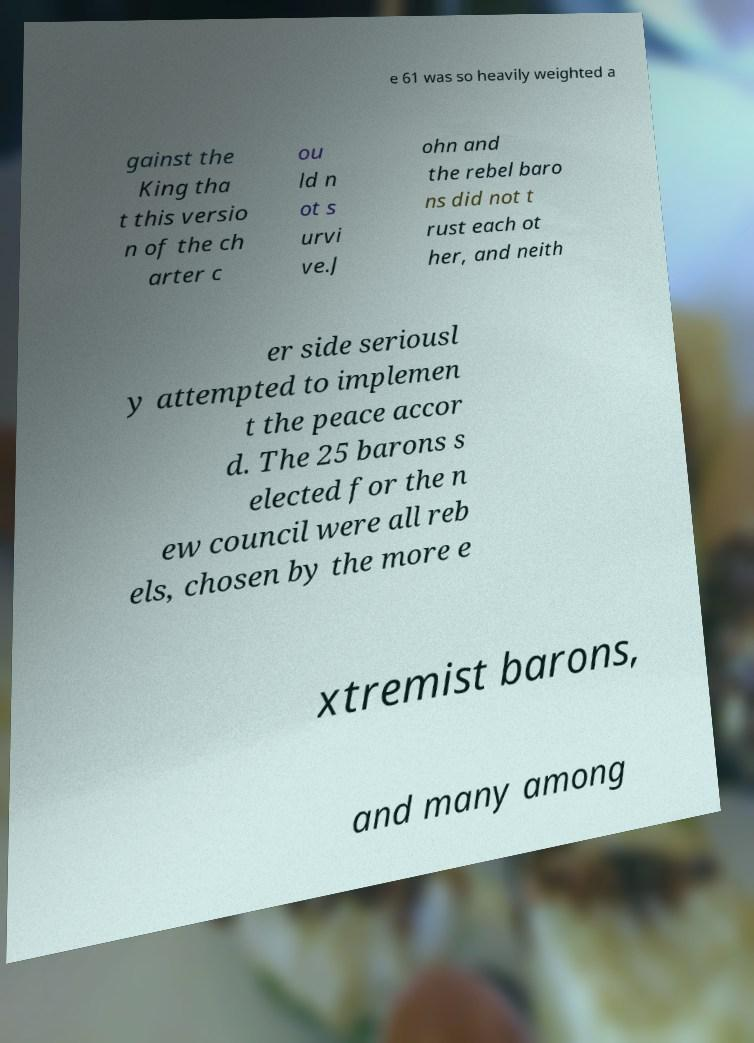There's text embedded in this image that I need extracted. Can you transcribe it verbatim? e 61 was so heavily weighted a gainst the King tha t this versio n of the ch arter c ou ld n ot s urvi ve.J ohn and the rebel baro ns did not t rust each ot her, and neith er side seriousl y attempted to implemen t the peace accor d. The 25 barons s elected for the n ew council were all reb els, chosen by the more e xtremist barons, and many among 